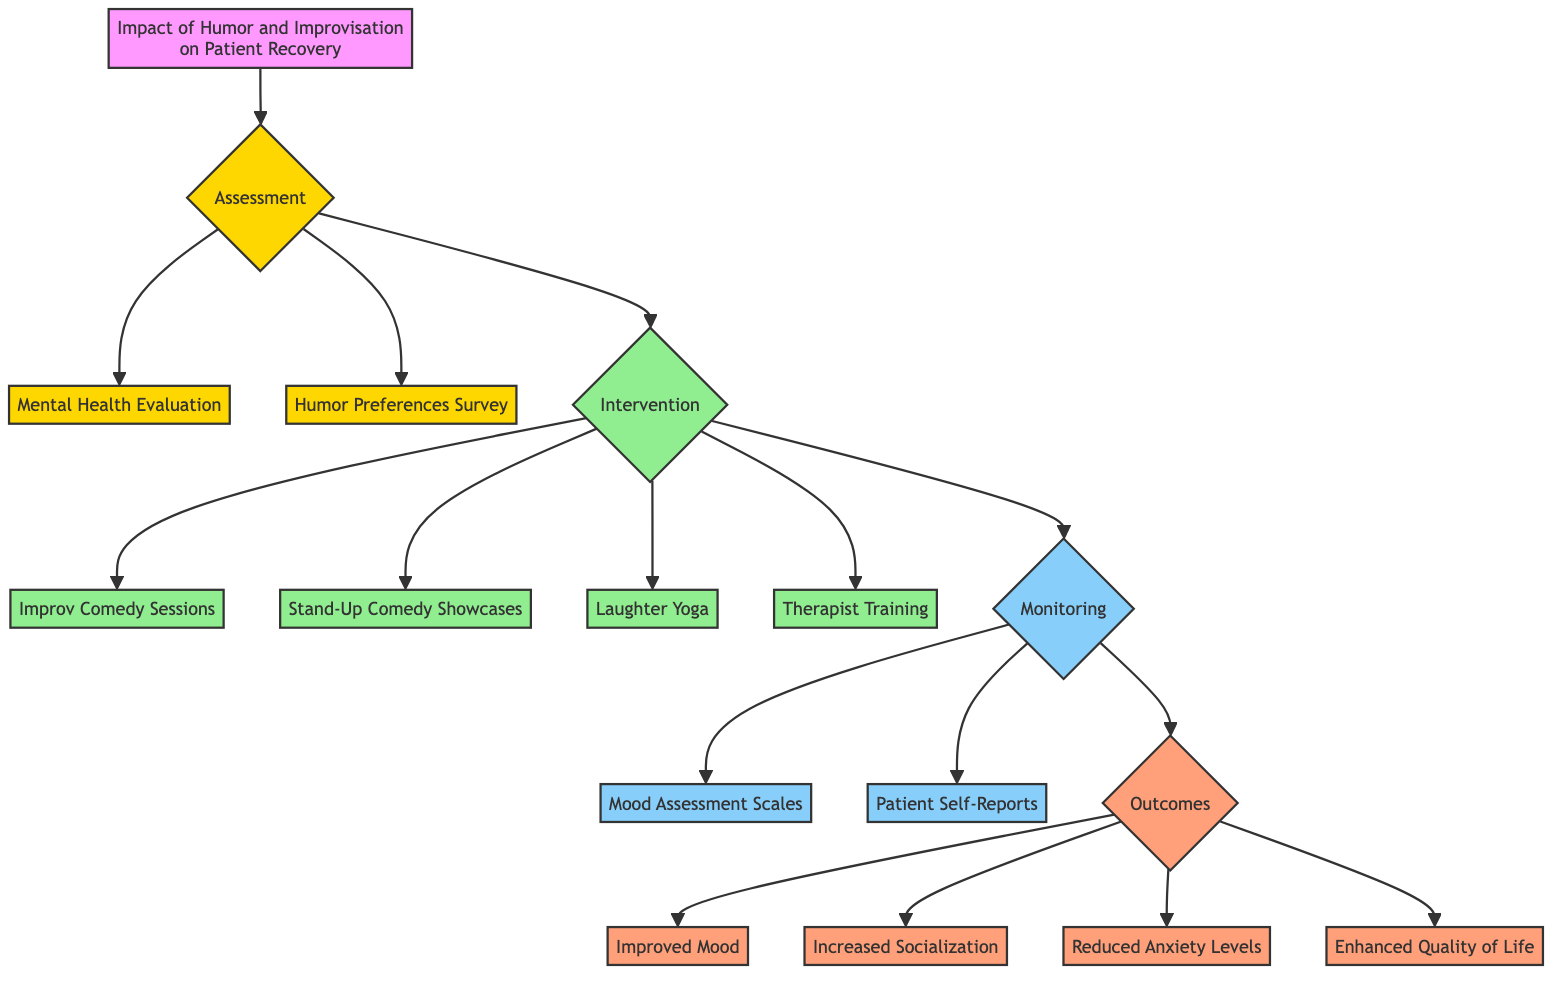What are the three assessment methods used in this pathway? The diagram shows three assessment methods under the Assessment section: Mental Health Evaluation, Humor Preferences Survey, and Intervention.
Answer: Mental Health Evaluation, Humor Preferences Survey How many intervention activities are outlined in the diagram? In the Intervention section, there are four identified activities: Improv Comedy Sessions, Stand-Up Comedy Showcases, Laughter Yoga, and Therapist Training.
Answer: Four What is the monitoring mechanism for assessing mood changes? The Monitoring section lists two mechanisms for assessing mood: Mood Assessment Scales and Patient Self-Reports. Each mechanism contributes to tracking the patient's mood changes.
Answer: Mood Assessment Scales, Patient Self-Reports Which node follows the Therapist Involvement in the intervention section? The diagram indicates that after the Therapist Training node, the flow leads to the Monitoring section, indicating the relationship between therapist training and monitoring progress.
Answer: Monitoring What type of outcomes are measured under the Long Term Impact section? The diagram indicates two long-term impact outcomes: Reduced Anxiety Levels and Enhanced Quality of Life, highlighting the effectiveness of humor-based interventions over time.
Answer: Reduced Anxiety Levels, Enhanced Quality of Life How are patients involved in the monitoring phase? The monitoring phase involves patients through Patient Self-Reports, where they document their feelings and responses to humor-based activities, indicating their active role in recovery tracking.
Answer: Patient Self-Reports What is the purpose of the Humor Preferences Survey in this pathway? The Humor Preferences Survey serves to identify the patient's humor style preferences, which informs the subsequent interventions designed to suit their individual humor receptivity.
Answer: Identify humor style preferences What outcome is directly related to social interactions? The diagram lists Increased Socialization as an outcome, which directly reflects the impact of humor interventions on the patients' interactions in group settings.
Answer: Increased Socialization 